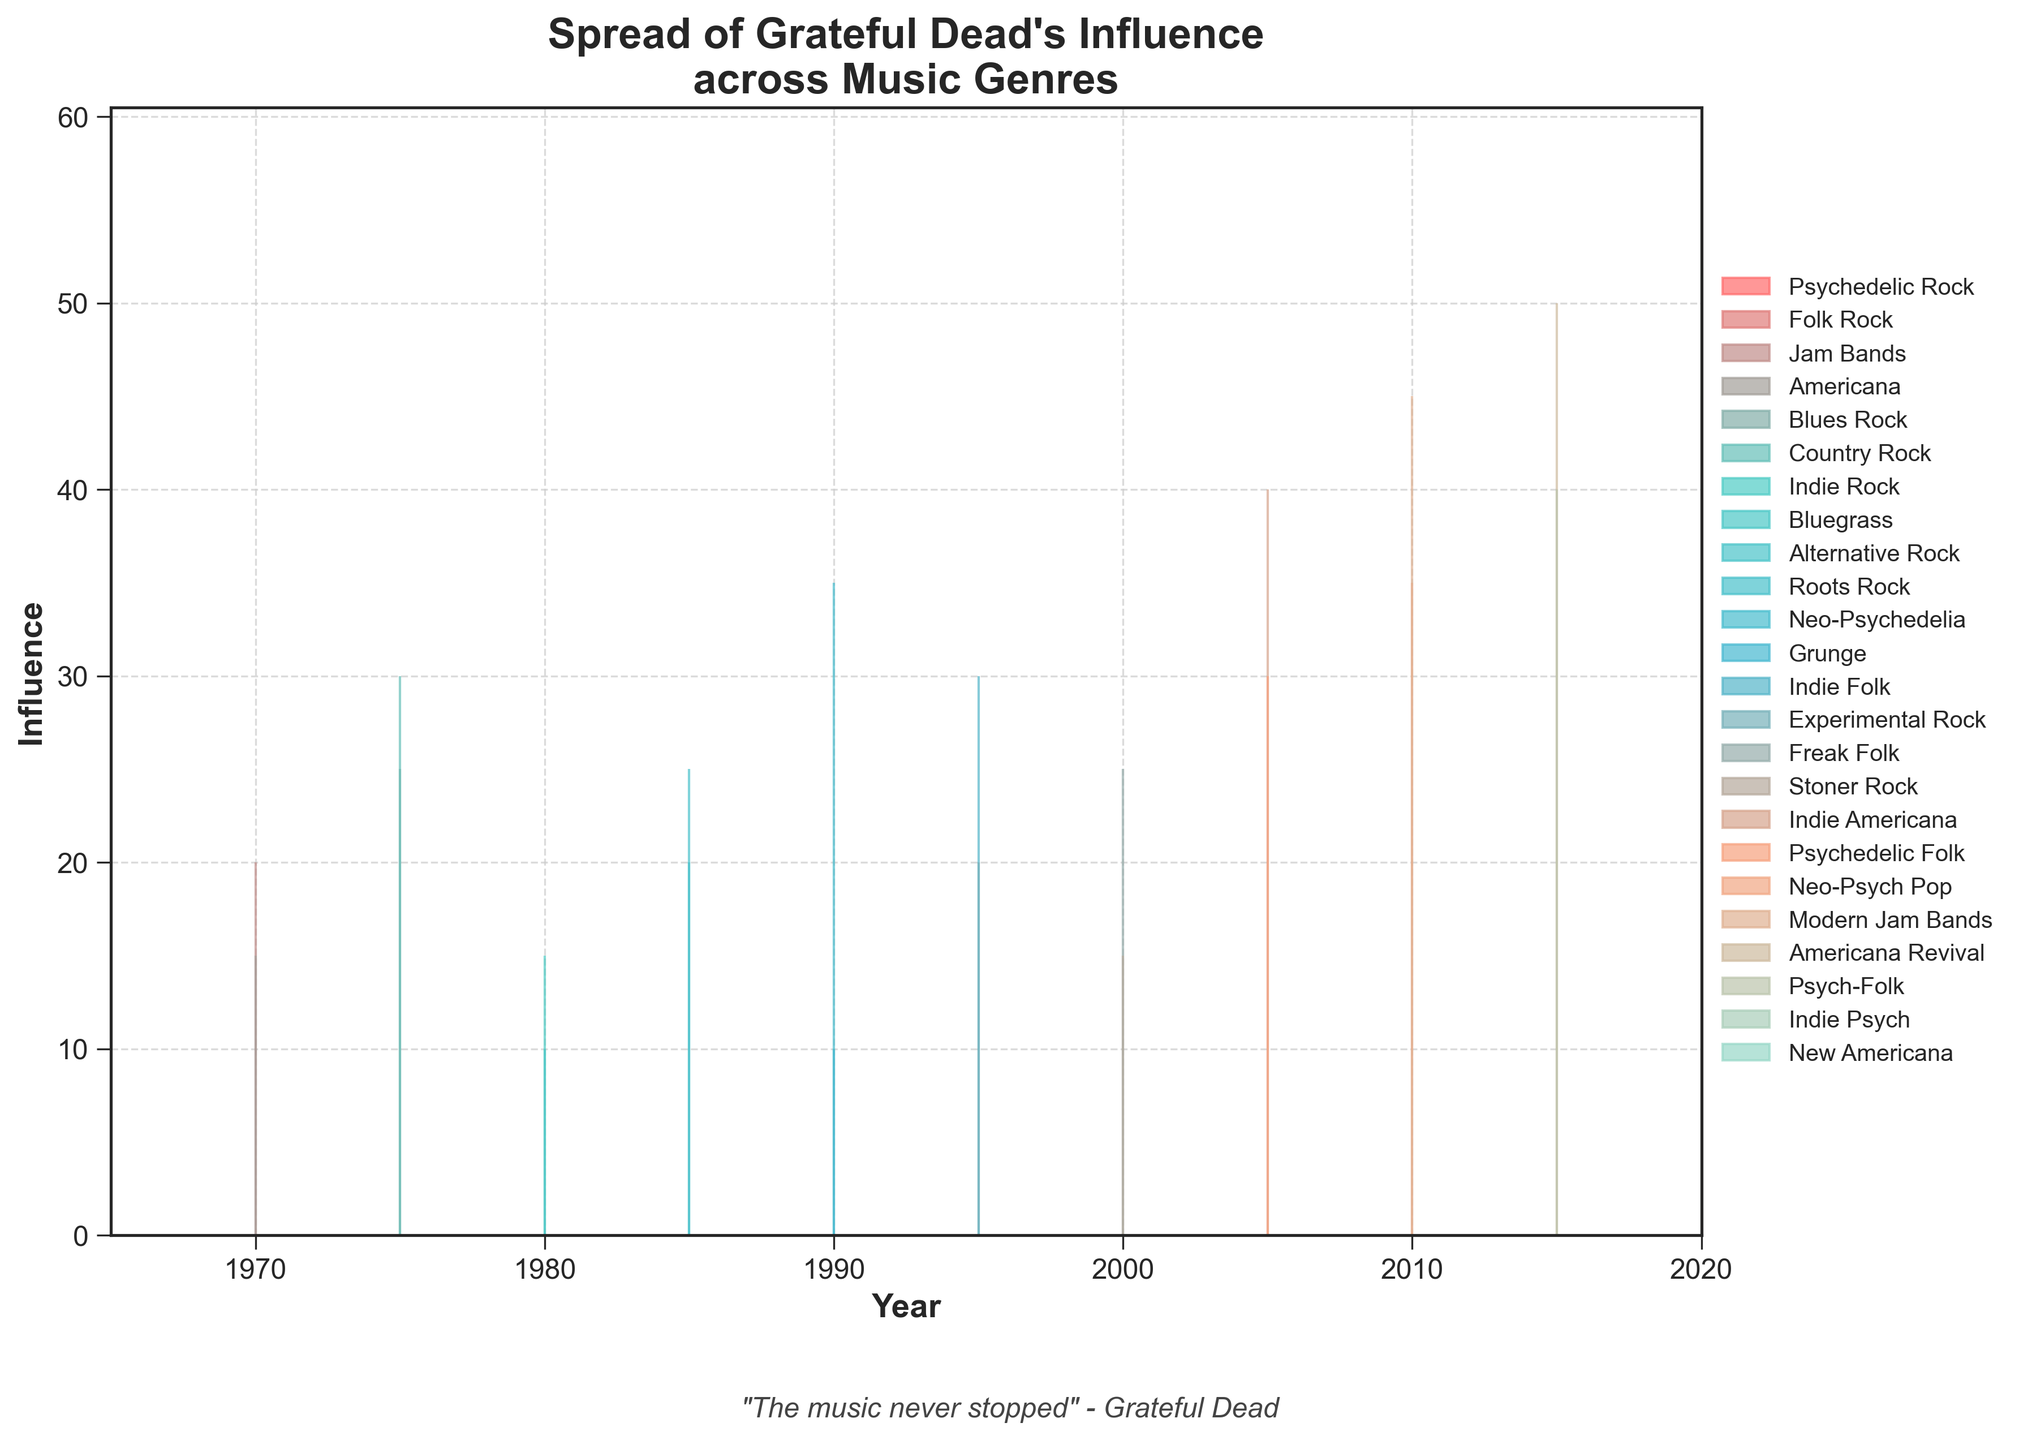Which music genre had the highest influence in 2020? To determine the highest influence in 2020, look at the influence values for 2020 and find the maximum value. The genres and their respective influences in 2020 are: Indie Psych (45) and New Americana (55). Therefore, the highest influence is for New Americana.
Answer: New Americana How many genres had an influence of 25 in any year? Count the categories which have a recorded influence of 25 across all years. These genres are: Blues Rock (1975), Roots Rock (1985), and Freak Folk (2000).
Answer: 3 What was the increase in influence of Americana from 1970 to 2015? Find Americana's influence in 1970 and 2015: 15 (1970) and 50 (2015). Subtract the earlier value from the later value, 50 - 15 = 35.
Answer: 35 Which genre showed the greatest increase in influence between 1995 and 2005? Observe the influence values in 1995 and 2005 for all genres. Calculate the differences: Indie Folk (0), Experimental Rock (5), Freak Folk (25), Stoner Rock (15). The highest increase is for Freak Folk: 25 - 0 = 25.
Answer: Freak Folk During which decade did the influence of Jam Bands see the most significant growth? Look at the influence values for Jam Bands across each decade: 20 (1970), 45 (2010). The increase is most significant from 20 to 45; hence the most significant growth occurred from 2000 to 2010.
Answer: 2000 to 2010 What is the average influence of Grateful Dead's influence on music genres in 1975? Influence values for 1975: Blues Rock (25), Country Rock (30). Average: (25 + 30) / 2.
Answer: 27.5 Which two genres had the same influence value in 1980? Look at the influence values: Indie Rock (15), Bluegrass (10). Both genres are different, so check their values. None of the values match.
Answer: None How did the influence on Psychedelic Rock change from 1965 to 1990? Identify influences for Psychedelic Rock: 10 (1965), 35 (1990). Increase is 35 - 10 = 25.
Answer: Increased by 25 Which genre was newly influenced in 2000 and what was its influence value? Identify genres first appearing in 2000: Freak Folk (25), Stoner Rock (15).
Answer: Two genres: Freak Folk (25), Stoner Rock (15) What was the total influence across all genres in 2010? Sum the influences of all genres in 2010: Neo-Psych Pop (35), Modern Jam Bands (45). Total = 35 + 45.
Answer: 80 